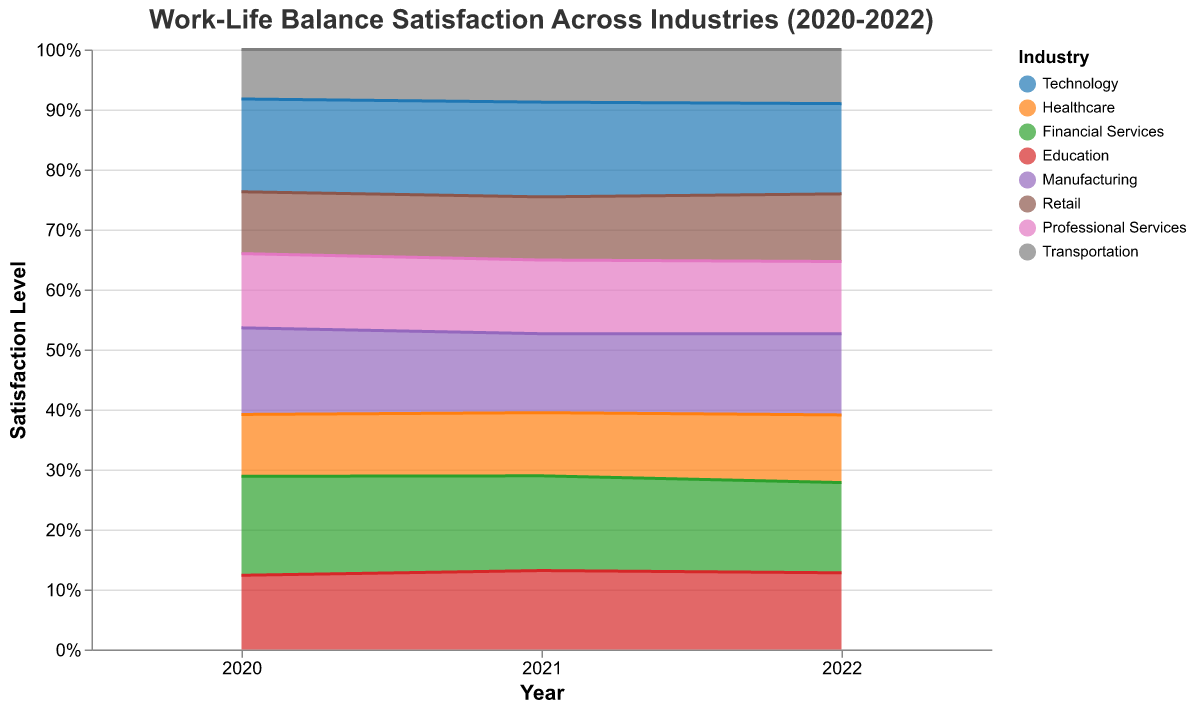What is the title of the chart? The title is usually displayed at the top of the chart and provides a summary of what the chart is about. Here, it states the focus on work-life balance satisfaction across industries from 2020 to 2022.
Answer: Work-Life Balance Satisfaction Across Industries (2020-2022) Which industry had the highest percentage of people "Very Satisfied" in 2022? By looking at the top segment of the stacked area for 2022, we can see which industry has the largest area for "Very Satisfied." Here, it is the Technology industry.
Answer: Technology What industry shows the largest improvement in "Very Satisfied" individuals from 2020 to 2022? Compare the top segments of the stacked areas for the years 2020 and 2022 and see which industry has the largest increase in size for "Very Satisfied." This calculation involves noting the difference in "Very Satisfied" percentages over the time period.
Answer: Technology Across the three years, does the Transportation industry show an increasing or decreasing trend in the "Dissatisfied" category? Observe the segment near the bottom representing "Dissatisfied" for Transportation across all three years and see if it is increasing or decreasing in size. The area decreases from 2020 to 2022.
Answer: Decreasing In 2021, which industry had the highest percentage of "Neutral" satisfaction? By examining the middle segment for each industry in 2021, identify the industry with the largest "Neutral" segment.
Answer: Transportation How does the percentage of "Very Dissatisfied" individuals in Professional Services in 2022 compare to the percentage in Manufacturing in 2021? Locate the respective segments for "Very Dissatisfied" in the specified industries and years and visually compare their sizes. The "Very Dissatisfied" segment for Professional Services in 2022 is smaller.
Answer: Smaller Which year had the highest overall satisfaction (combining "Very Satisfied" and "Satisfied") in Financial Services? Sum the top two segments ("Very Satisfied" and "Satisfied") for each year and compare them visually; 2022 looks the largest.
Answer: 2022 Which industry has the most balanced satisfaction levels across the three years, i.e., equal distribution among "Very Satisfied," "Satisfied," "Neutral," "Dissatisfied," and "Very Dissatisfied"? Look for the industry where the segments seem most evenly distributed in height across all years. Retail seems to have the most balanced distribution.
Answer: Retail Which industry has the largest decline in "Dissatisfied" individuals from 2020 to 2022? Compare the "Dissatisfied" segments from 2020 to 2022 for each industry and determine the largest decline. The drop is notable in Transportation.
Answer: Transportation 